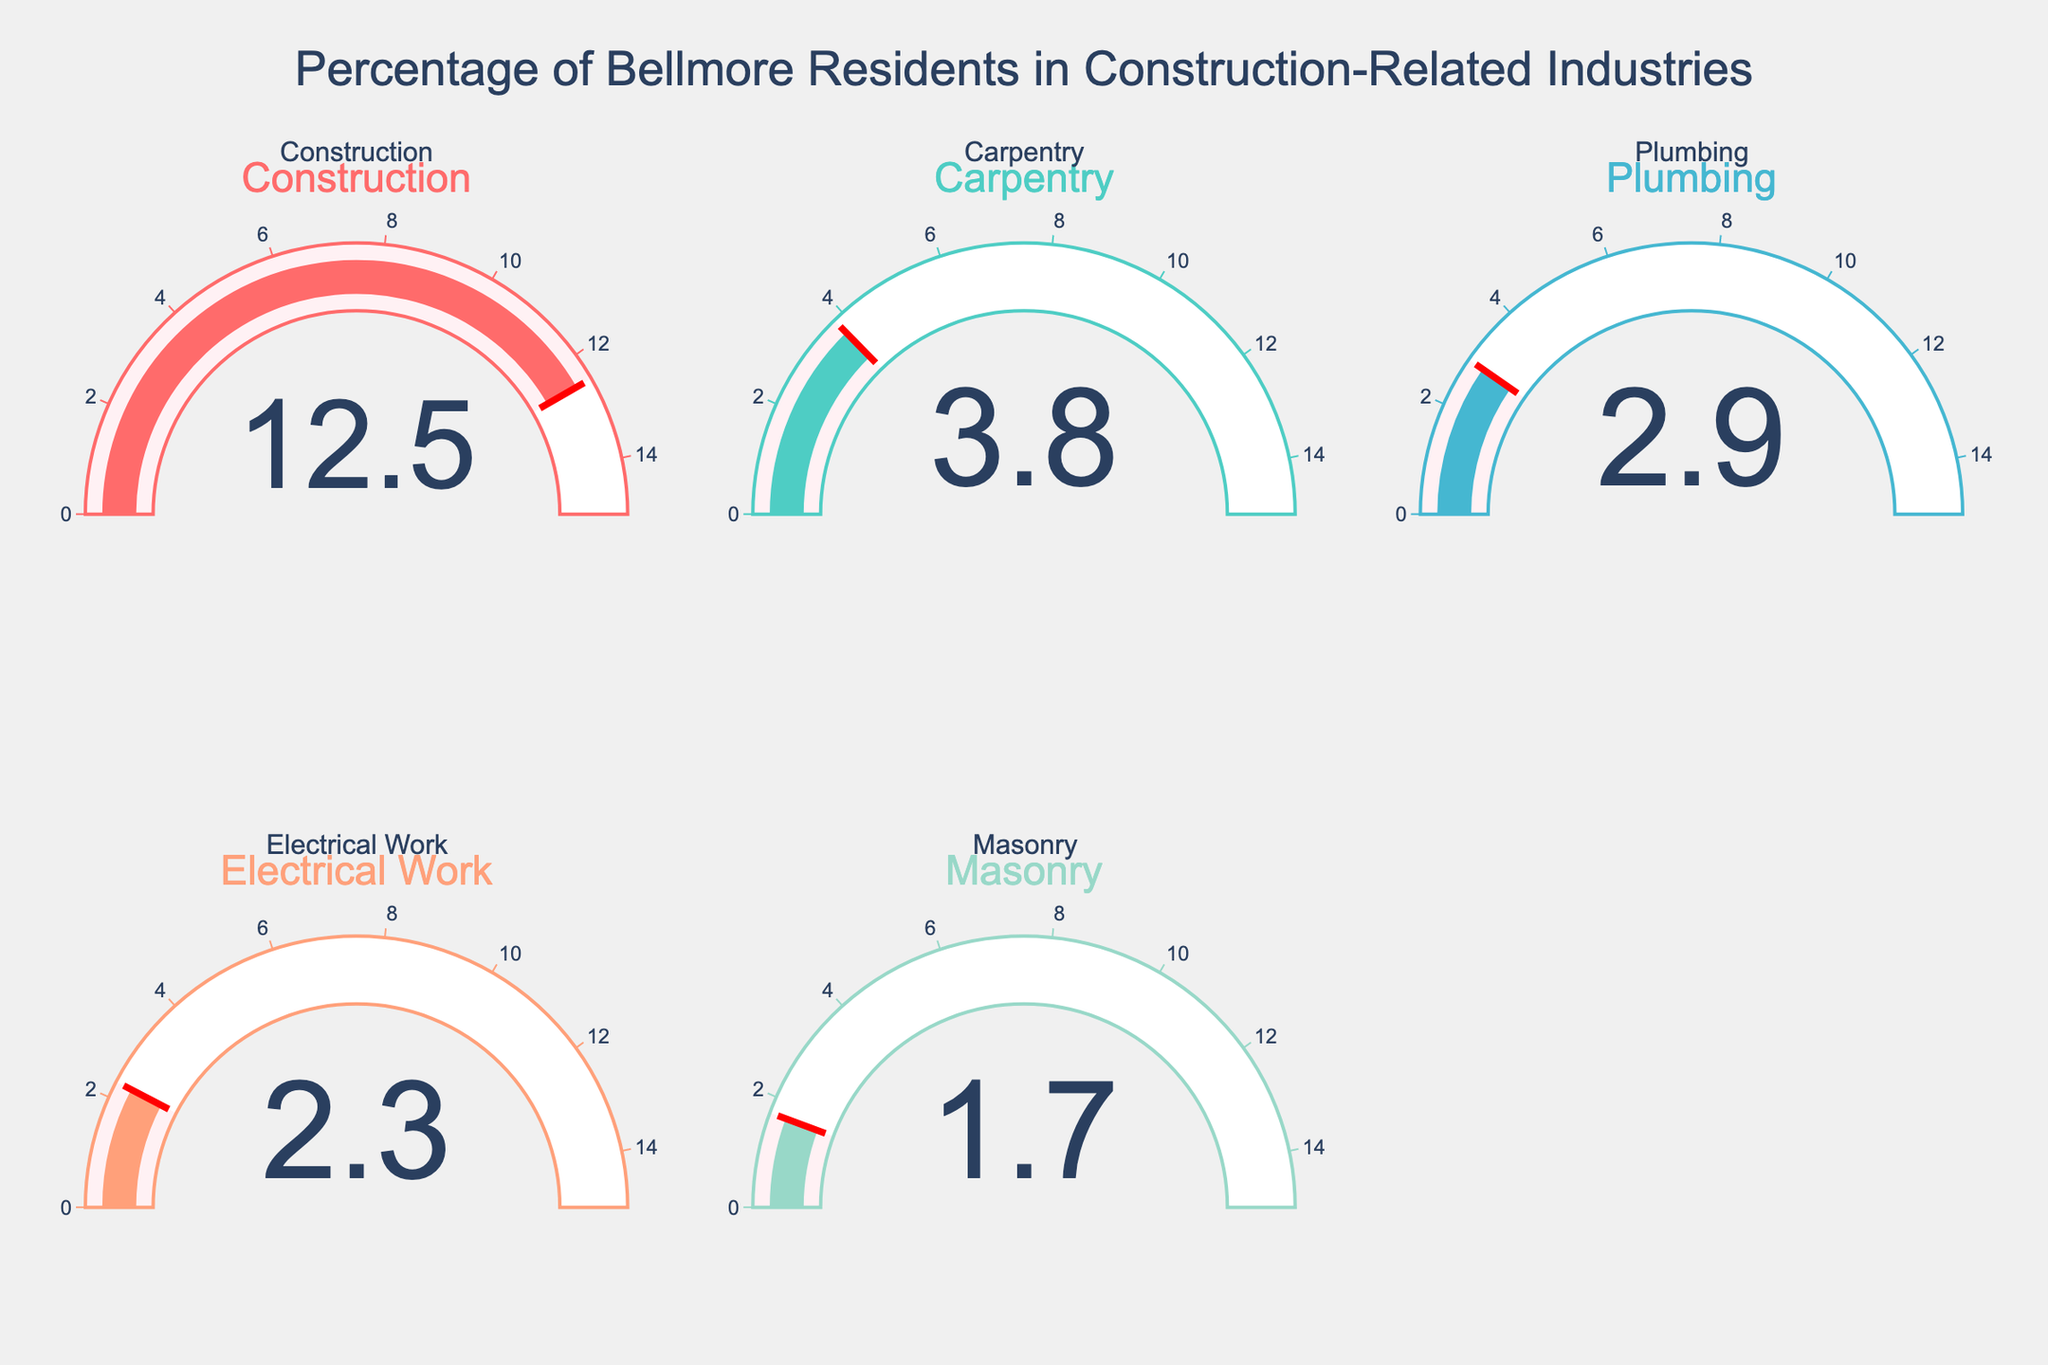How many different industries are displayed in the figure? The figure contains gauges for each represented industry. By counting the titles of the gauges, you can see there are five industries listed.
Answer: 5 What is the title of the figure? The figure has a title located at the top which reads "Percentage of Bellmore Residents in Construction-Related Industries."
Answer: Percentage of Bellmore Residents in Construction-Related Industries Which construction-related industry has the lowest percentage of employment? By examining the values in the gauges, "Masonry" has the smallest percentage at 1.7%.
Answer: Masonry What is the sum of the percentages for Carpentry and Plumbing? Identify the percentages for Carpentry (3.8%) and Plumbing (2.9%) and add them together: 3.8 + 2.9 = 6.7.
Answer: 6.7 How does the percentage of residents employed in Construction compare to the percentage employed in Electrical Work? The percentage for Construction is 12.5%, which is significantly higher than the Electrical Work percentage of 2.3%.
Answer: Construction is higher Which industry occupies a gauge chart and has a percentage higher than 3% but lower than 4%? Only Carpentry fits this criterion, having a percentage of 3.8%.
Answer: Carpentry If the total percentage for all industries is considered 23.2%, what is the combined percentage for non-Construction industries? Subtract the Construction percentage from the total percentage: 23.2 - 12.5 = 10.7.
Answer: 10.7 What is the average percentage of employment in the listed industries? Sum all the percentages (12.5 + 3.8 + 2.9 + 2.3 + 1.7 = 23.2) and divide by the number of industries (5): 23.2 / 5 = 4.64.
Answer: 4.64 